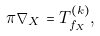<formula> <loc_0><loc_0><loc_500><loc_500>\pi \nabla _ { X } = T _ { f _ { X } } ^ { ( k ) } ,</formula> 